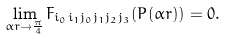<formula> <loc_0><loc_0><loc_500><loc_500>\lim _ { { \alpha r } \to \frac { \pi } { 4 } } F _ { i _ { 0 } i _ { 1 } j _ { 0 } j _ { 1 } j _ { 2 } j _ { 3 } } ( P ( { \alpha r } ) ) = 0 .</formula> 